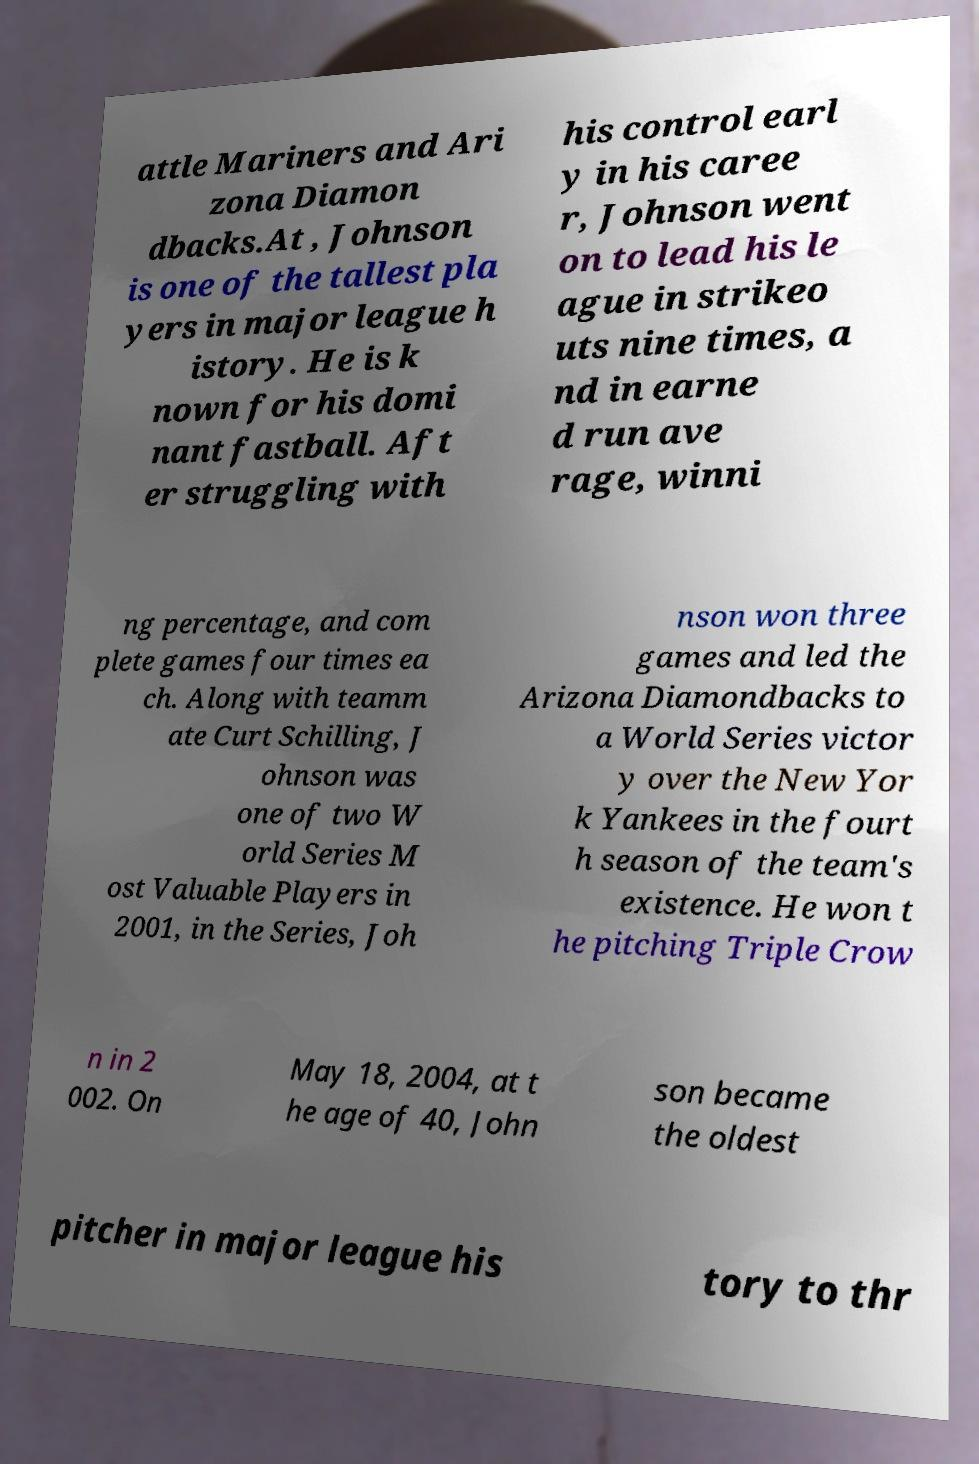Could you assist in decoding the text presented in this image and type it out clearly? attle Mariners and Ari zona Diamon dbacks.At , Johnson is one of the tallest pla yers in major league h istory. He is k nown for his domi nant fastball. Aft er struggling with his control earl y in his caree r, Johnson went on to lead his le ague in strikeo uts nine times, a nd in earne d run ave rage, winni ng percentage, and com plete games four times ea ch. Along with teamm ate Curt Schilling, J ohnson was one of two W orld Series M ost Valuable Players in 2001, in the Series, Joh nson won three games and led the Arizona Diamondbacks to a World Series victor y over the New Yor k Yankees in the fourt h season of the team's existence. He won t he pitching Triple Crow n in 2 002. On May 18, 2004, at t he age of 40, John son became the oldest pitcher in major league his tory to thr 